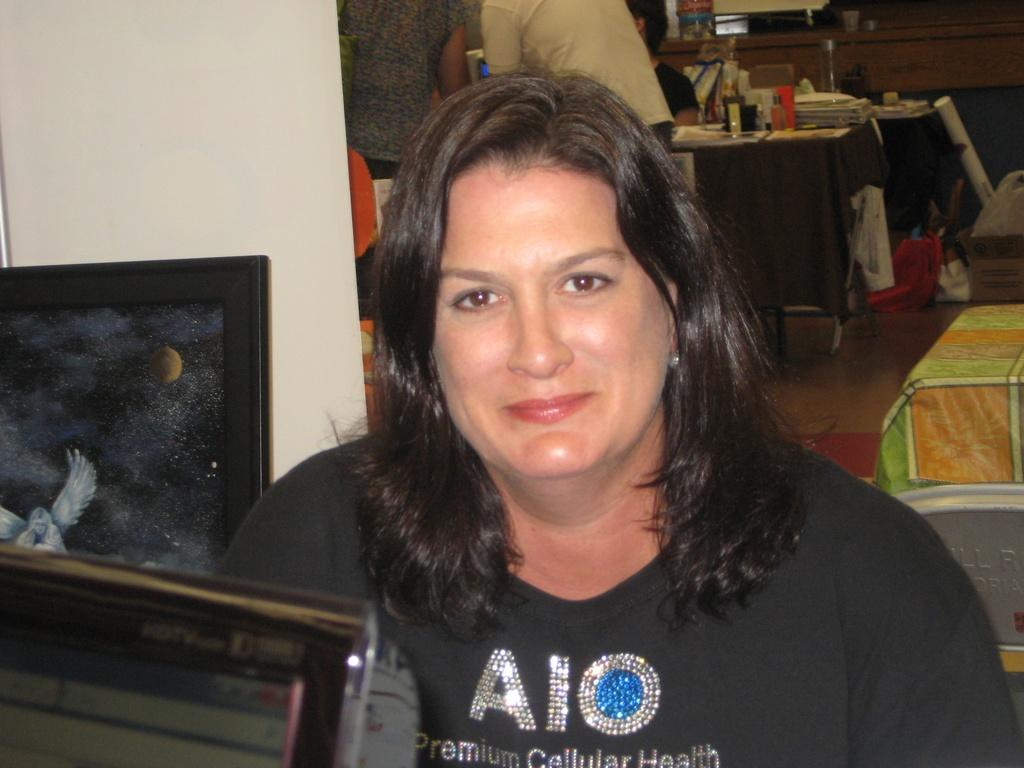What are the persons in the image wearing? The persons in the image are wearing clothes. What can be seen on the tables in the image? The tables in the image are covered with clothes. What is on the wall in the image? There is a painting on the wall in the image. Can you see a giraffe looking out of the window in the image? There is no giraffe or window present in the image. 